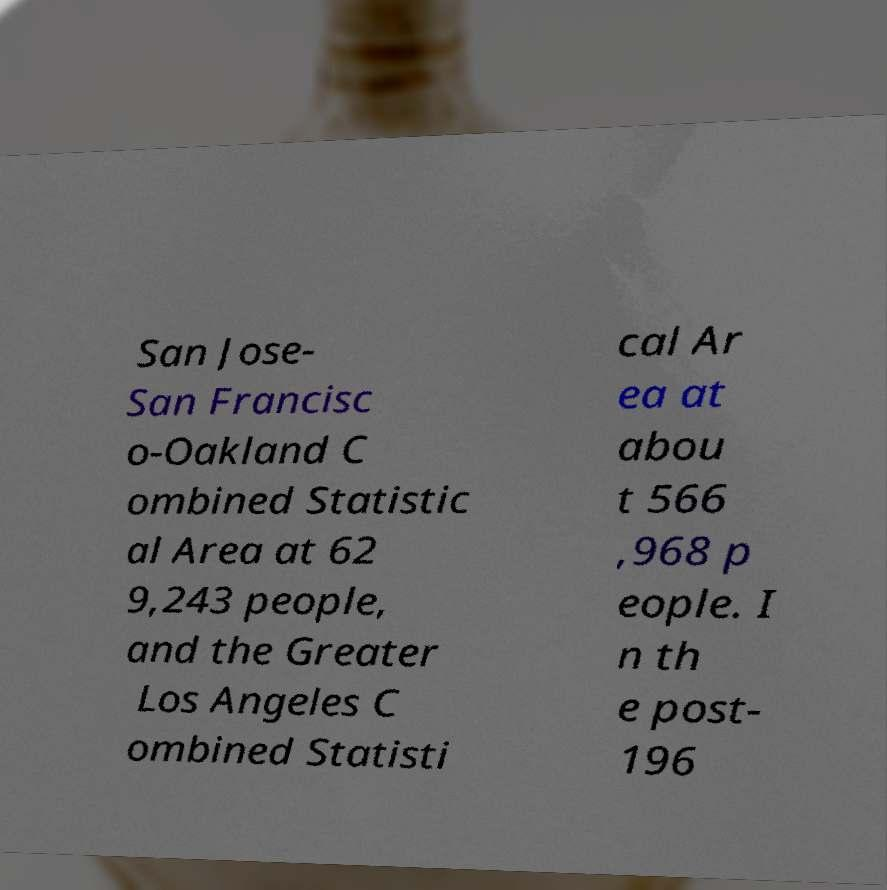Please identify and transcribe the text found in this image. San Jose- San Francisc o-Oakland C ombined Statistic al Area at 62 9,243 people, and the Greater Los Angeles C ombined Statisti cal Ar ea at abou t 566 ,968 p eople. I n th e post- 196 